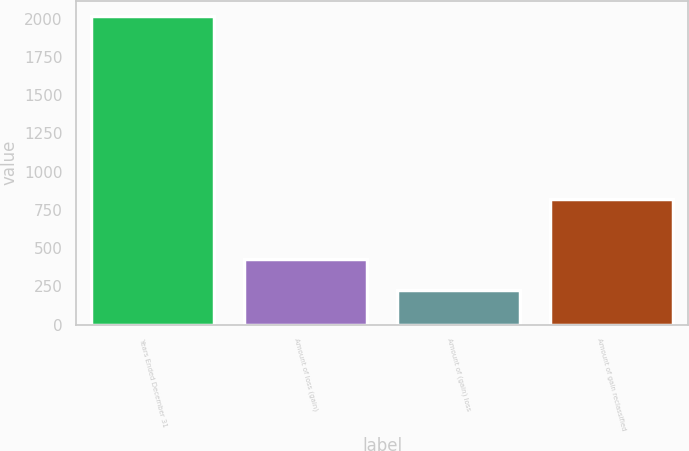Convert chart. <chart><loc_0><loc_0><loc_500><loc_500><bar_chart><fcel>Years Ended December 31<fcel>Amount of loss (gain)<fcel>Amount of (gain) loss<fcel>Amount of gain reclassified<nl><fcel>2016<fcel>425.6<fcel>226.8<fcel>823.2<nl></chart> 